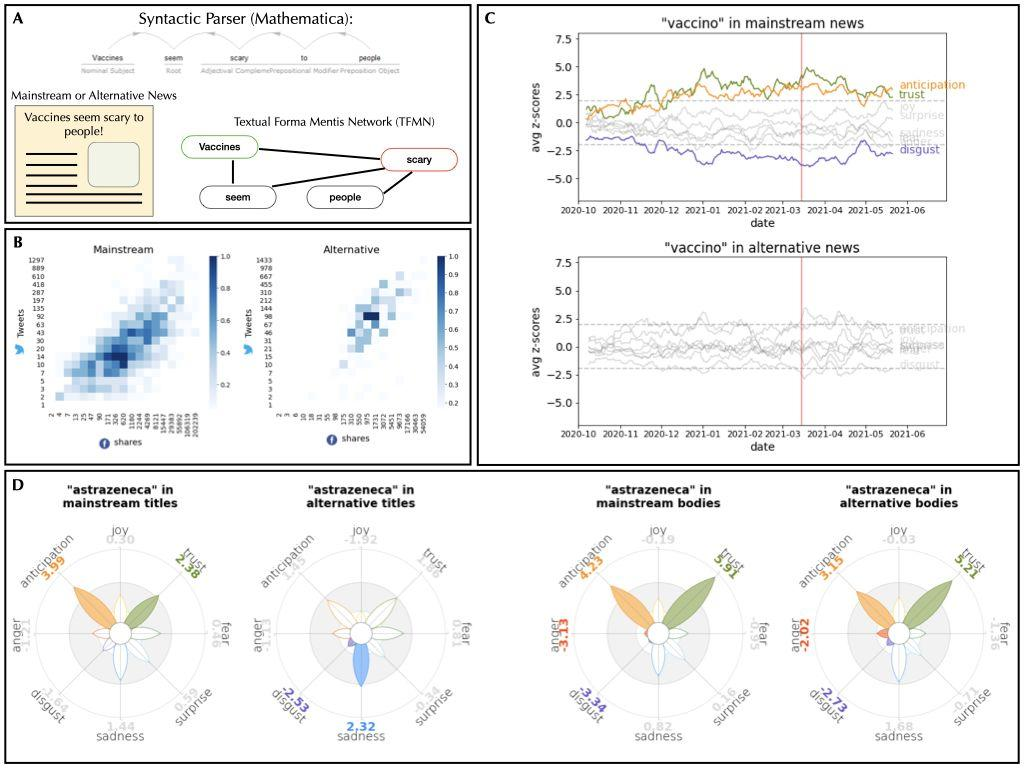How do the emotional responses associated with the term "AstraZeneca" differ between mainstream and alternative titles, as reflected in Figure D? Figure D provides emotion profiles for the term 'AstraZeneca' in news titles. In mainstream titles, the dominant emotions are anticipation and joy, suggesting a generally positive or anticipatory outlook. Conversely, alternative titles show a similar pattern, but with a slightly lower intensity of joy and anticipation. Both types of media exhibit low levels of sadness and disgust, but it's interesting to see that alternative news has a slight spike in sadness, which might suggest more critical or cautious coverage compared to mainstream. 